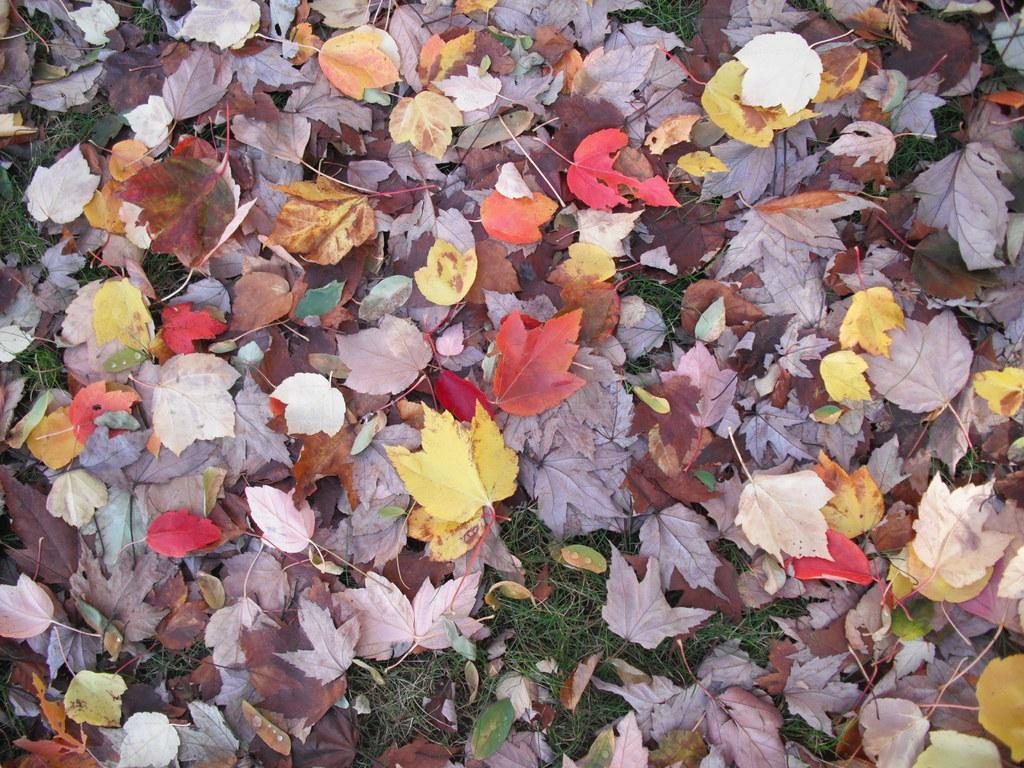What type of vegetation can be seen in the image? There are leaves in the image. Where are the leaves located? The leaves are on the grass. What does the dad do in the image? There is no dad present in the image; it only features leaves on the grass. 